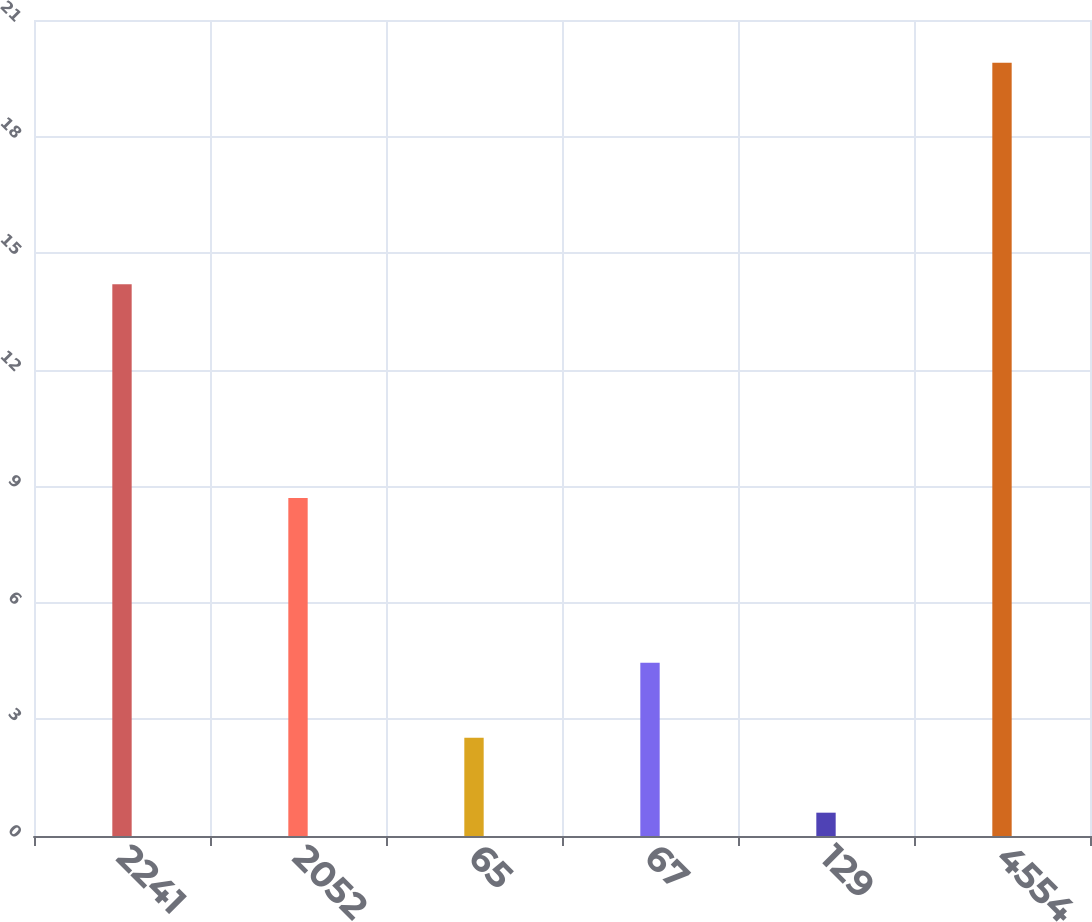Convert chart. <chart><loc_0><loc_0><loc_500><loc_500><bar_chart><fcel>2241<fcel>2052<fcel>65<fcel>67<fcel>129<fcel>4554<nl><fcel>14.2<fcel>8.7<fcel>2.53<fcel>4.46<fcel>0.6<fcel>19.9<nl></chart> 